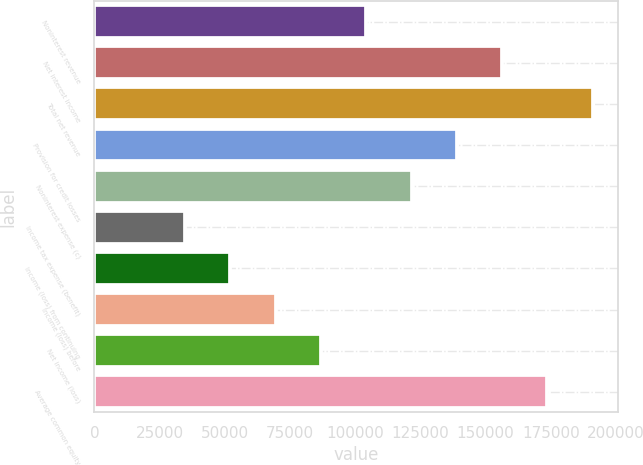<chart> <loc_0><loc_0><loc_500><loc_500><bar_chart><fcel>Noninterest revenue<fcel>Net interest income<fcel>Total net revenue<fcel>Provision for credit losses<fcel>Noninterest expense (c)<fcel>Income tax expense (benefit)<fcel>Income (loss) from continuing<fcel>Income (loss) before<fcel>Net income (loss)<fcel>Average common equity<nl><fcel>104229<fcel>156340<fcel>191082<fcel>138970<fcel>121599<fcel>34746.2<fcel>52116.8<fcel>69487.4<fcel>86858<fcel>173711<nl></chart> 